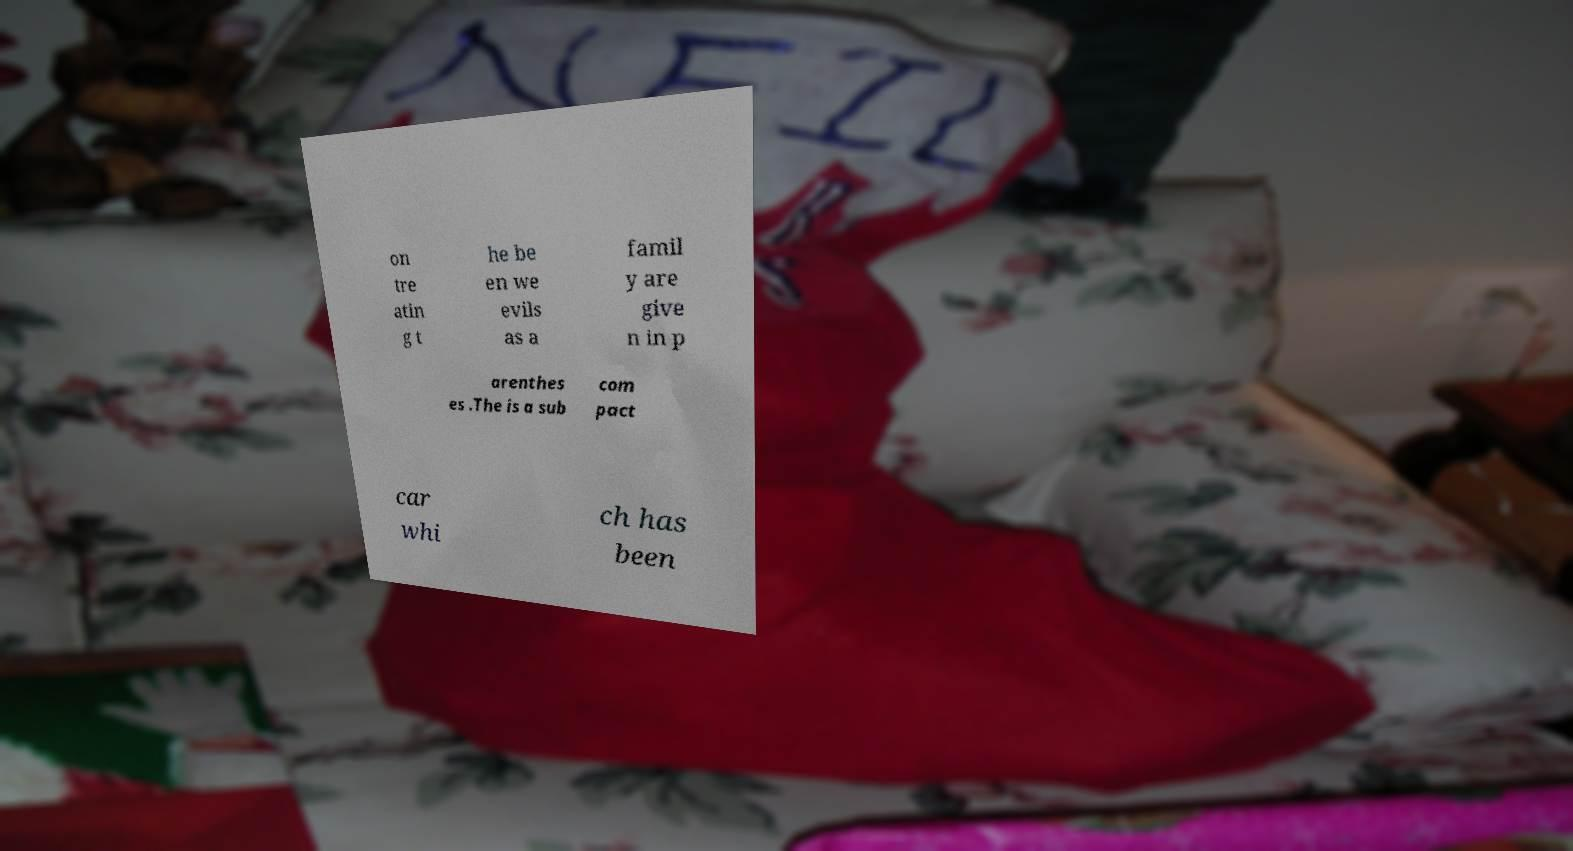I need the written content from this picture converted into text. Can you do that? on tre atin g t he be en we evils as a famil y are give n in p arenthes es .The is a sub com pact car whi ch has been 